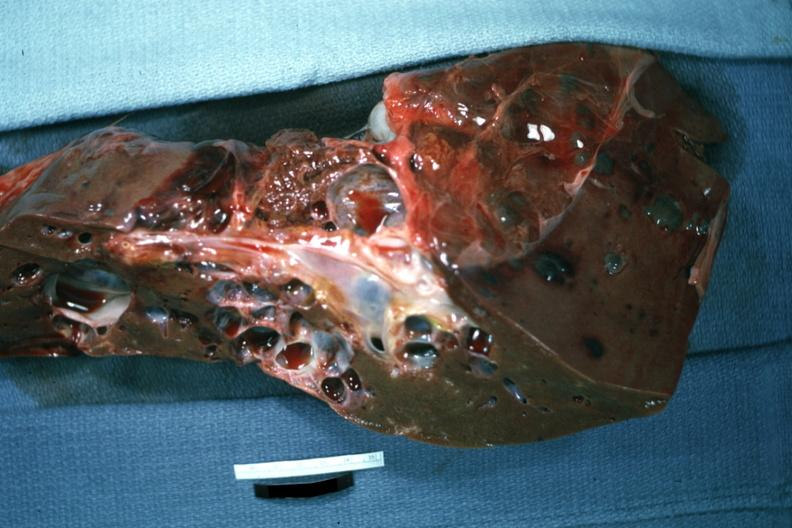s hepatobiliary present?
Answer the question using a single word or phrase. Yes 